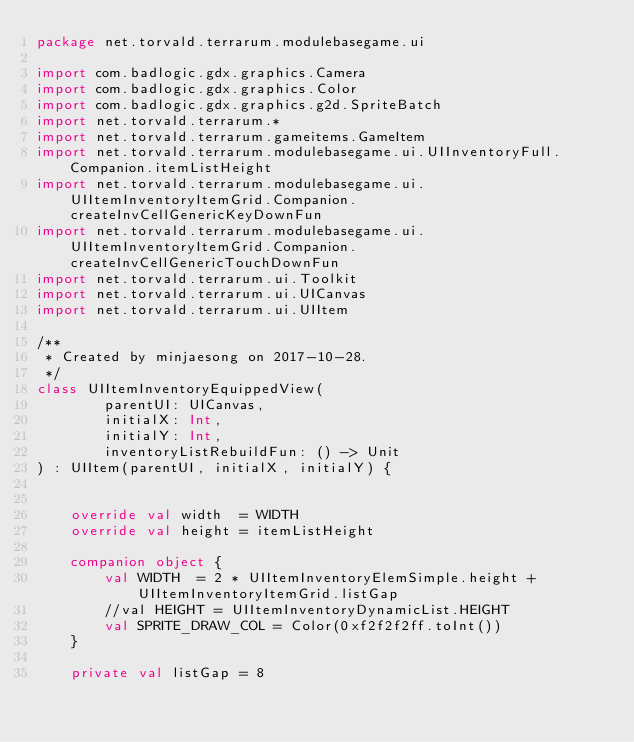Convert code to text. <code><loc_0><loc_0><loc_500><loc_500><_Kotlin_>package net.torvald.terrarum.modulebasegame.ui

import com.badlogic.gdx.graphics.Camera
import com.badlogic.gdx.graphics.Color
import com.badlogic.gdx.graphics.g2d.SpriteBatch
import net.torvald.terrarum.*
import net.torvald.terrarum.gameitems.GameItem
import net.torvald.terrarum.modulebasegame.ui.UIInventoryFull.Companion.itemListHeight
import net.torvald.terrarum.modulebasegame.ui.UIItemInventoryItemGrid.Companion.createInvCellGenericKeyDownFun
import net.torvald.terrarum.modulebasegame.ui.UIItemInventoryItemGrid.Companion.createInvCellGenericTouchDownFun
import net.torvald.terrarum.ui.Toolkit
import net.torvald.terrarum.ui.UICanvas
import net.torvald.terrarum.ui.UIItem

/**
 * Created by minjaesong on 2017-10-28.
 */
class UIItemInventoryEquippedView(
        parentUI: UICanvas,
        initialX: Int,
        initialY: Int,
        inventoryListRebuildFun: () -> Unit
) : UIItem(parentUI, initialX, initialY) {


    override val width  = WIDTH
    override val height = itemListHeight

    companion object {
        val WIDTH  = 2 * UIItemInventoryElemSimple.height + UIItemInventoryItemGrid.listGap
        //val HEIGHT = UIItemInventoryDynamicList.HEIGHT
        val SPRITE_DRAW_COL = Color(0xf2f2f2ff.toInt())
    }

    private val listGap = 8
</code> 